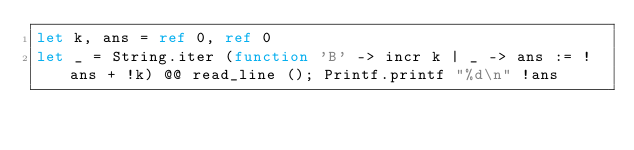Convert code to text. <code><loc_0><loc_0><loc_500><loc_500><_OCaml_>let k, ans = ref 0, ref 0
let _ = String.iter (function 'B' -> incr k | _ -> ans := !ans + !k) @@ read_line (); Printf.printf "%d\n" !ans</code> 